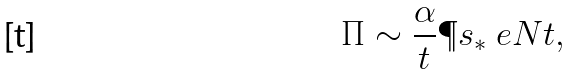<formula> <loc_0><loc_0><loc_500><loc_500>\Pi \sim \frac { \alpha } { t } \P s _ { \ast } \ e { N t } ,</formula> 